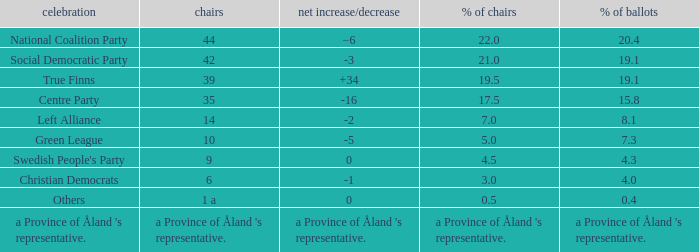When there was a net gain/loss of +34, what was the percentage of seats that party held? 19.5. 